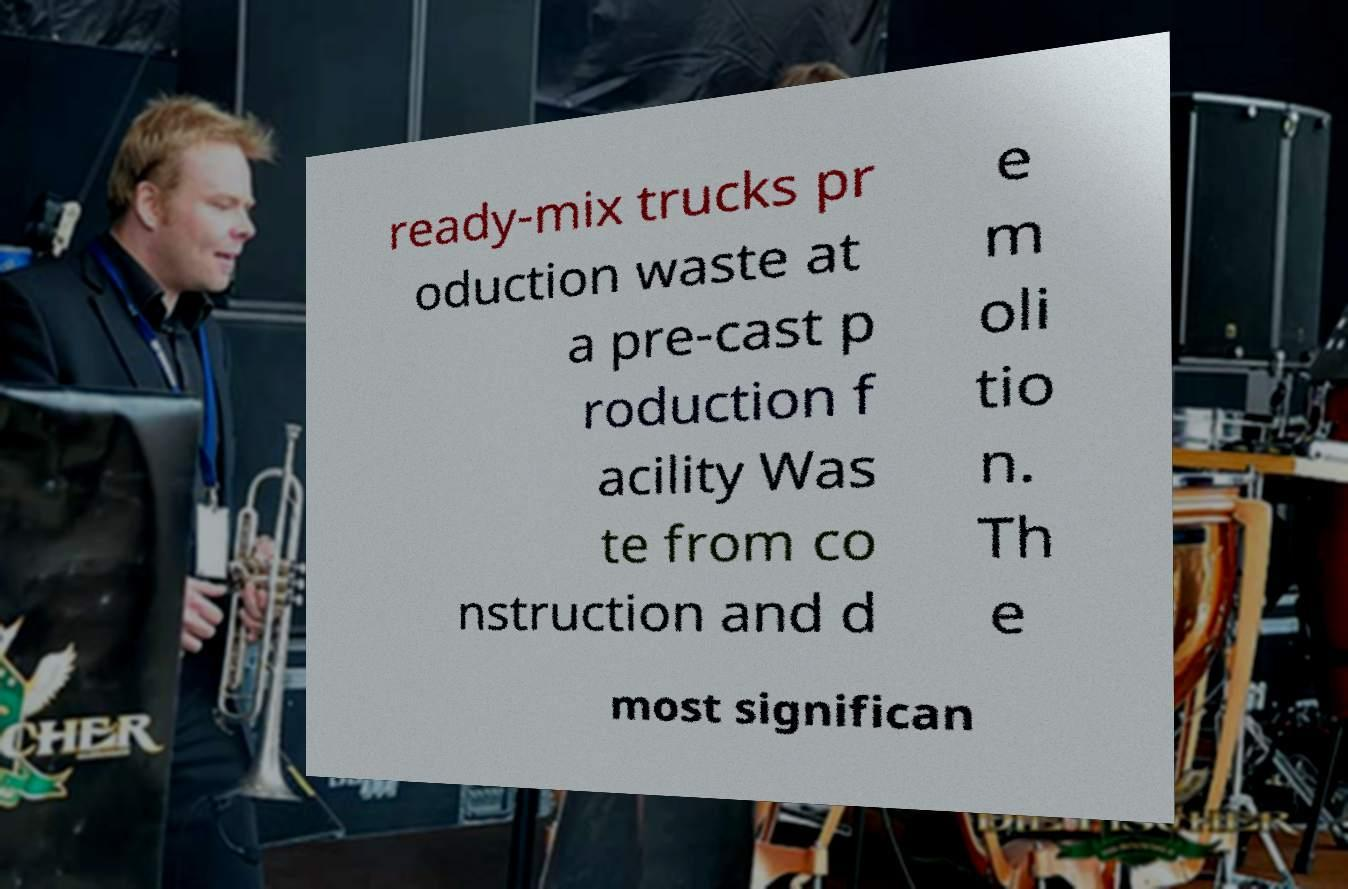I need the written content from this picture converted into text. Can you do that? ready-mix trucks pr oduction waste at a pre-cast p roduction f acility Was te from co nstruction and d e m oli tio n. Th e most significan 